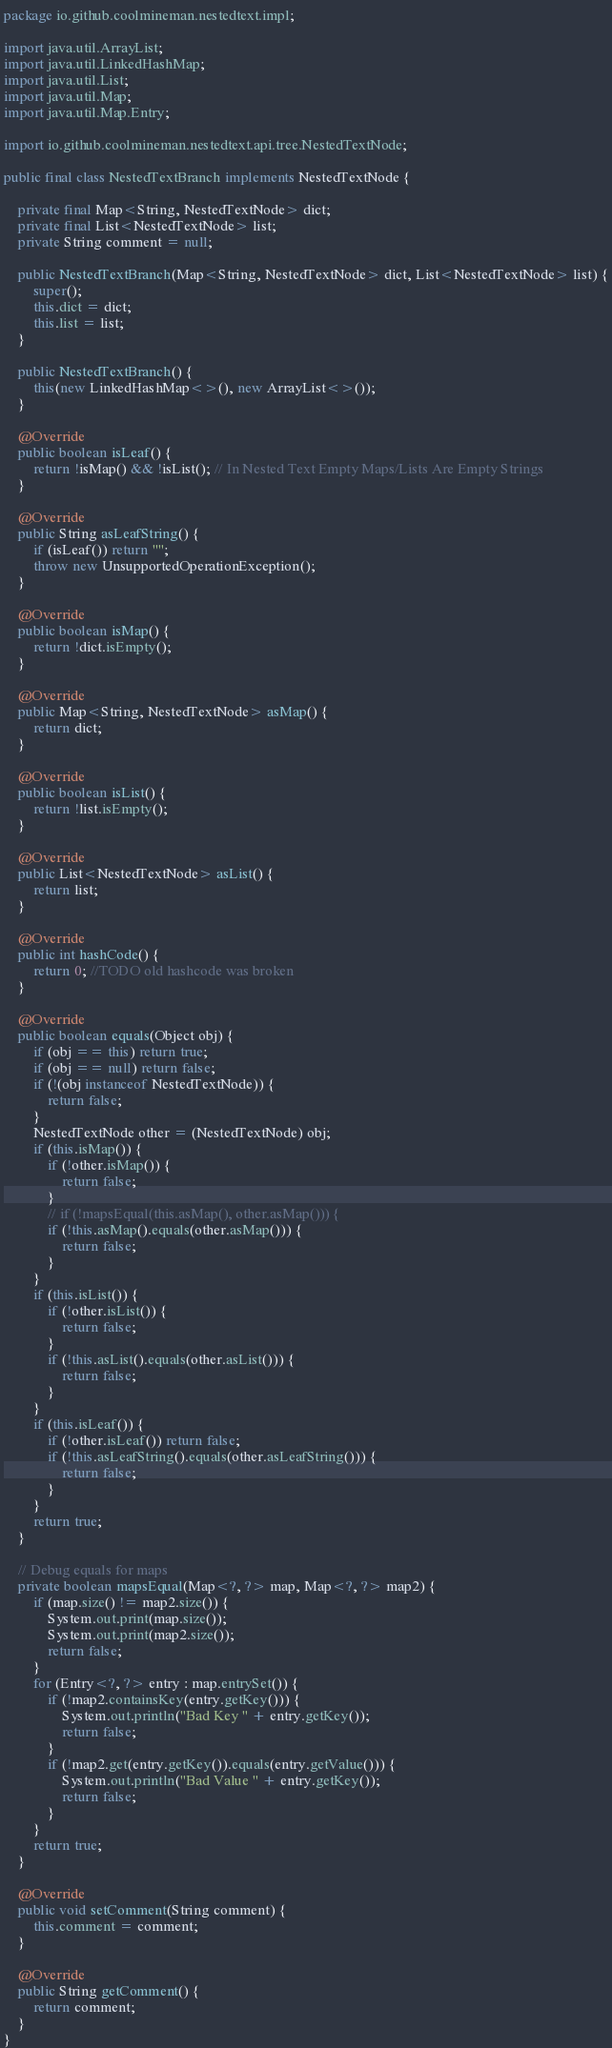Convert code to text. <code><loc_0><loc_0><loc_500><loc_500><_Java_>package io.github.coolmineman.nestedtext.impl;

import java.util.ArrayList;
import java.util.LinkedHashMap;
import java.util.List;
import java.util.Map;
import java.util.Map.Entry;

import io.github.coolmineman.nestedtext.api.tree.NestedTextNode;

public final class NestedTextBranch implements NestedTextNode {

    private final Map<String, NestedTextNode> dict;
    private final List<NestedTextNode> list;
    private String comment = null;

    public NestedTextBranch(Map<String, NestedTextNode> dict, List<NestedTextNode> list) {
        super();
        this.dict = dict;
        this.list = list;
    }

    public NestedTextBranch() {
        this(new LinkedHashMap<>(), new ArrayList<>());
    }

    @Override
    public boolean isLeaf() {
        return !isMap() && !isList(); // In Nested Text Empty Maps/Lists Are Empty Strings
    }

    @Override
    public String asLeafString() {
        if (isLeaf()) return "";
        throw new UnsupportedOperationException();
    }

    @Override
    public boolean isMap() {
        return !dict.isEmpty();
    }

    @Override
    public Map<String, NestedTextNode> asMap() {
        return dict;
    }

    @Override
    public boolean isList() {
        return !list.isEmpty();
    }

    @Override
    public List<NestedTextNode> asList() {
        return list;
    }

    @Override
    public int hashCode() {
        return 0; //TODO old hashcode was broken
    }

    @Override
    public boolean equals(Object obj) {
        if (obj == this) return true;
        if (obj == null) return false;
        if (!(obj instanceof NestedTextNode)) {
            return false;
        }
        NestedTextNode other = (NestedTextNode) obj;
        if (this.isMap()) {
            if (!other.isMap()) {
                return false;
            }
            // if (!mapsEqual(this.asMap(), other.asMap())) {
            if (!this.asMap().equals(other.asMap())) {
                return false;
            }
        }
        if (this.isList()) {
            if (!other.isList()) {
                return false;
            }
            if (!this.asList().equals(other.asList())) {
                return false;
            }
        }
        if (this.isLeaf()) {
            if (!other.isLeaf()) return false;
            if (!this.asLeafString().equals(other.asLeafString())) {
                return false;
            }
        }
        return true;
    }

    // Debug equals for maps
    private boolean mapsEqual(Map<?, ?> map, Map<?, ?> map2) {
        if (map.size() != map2.size()) {
            System.out.print(map.size());
            System.out.print(map2.size());
            return false;
        }
        for (Entry<?, ?> entry : map.entrySet()) {
            if (!map2.containsKey(entry.getKey())) {
                System.out.println("Bad Key " + entry.getKey());
                return false;
            }
            if (!map2.get(entry.getKey()).equals(entry.getValue())) {
                System.out.println("Bad Value " + entry.getKey());
                return false;
            }
        }
        return true;
    }

    @Override
    public void setComment(String comment) {
        this.comment = comment;
    }

    @Override
    public String getComment() {
        return comment;
    }
}
</code> 